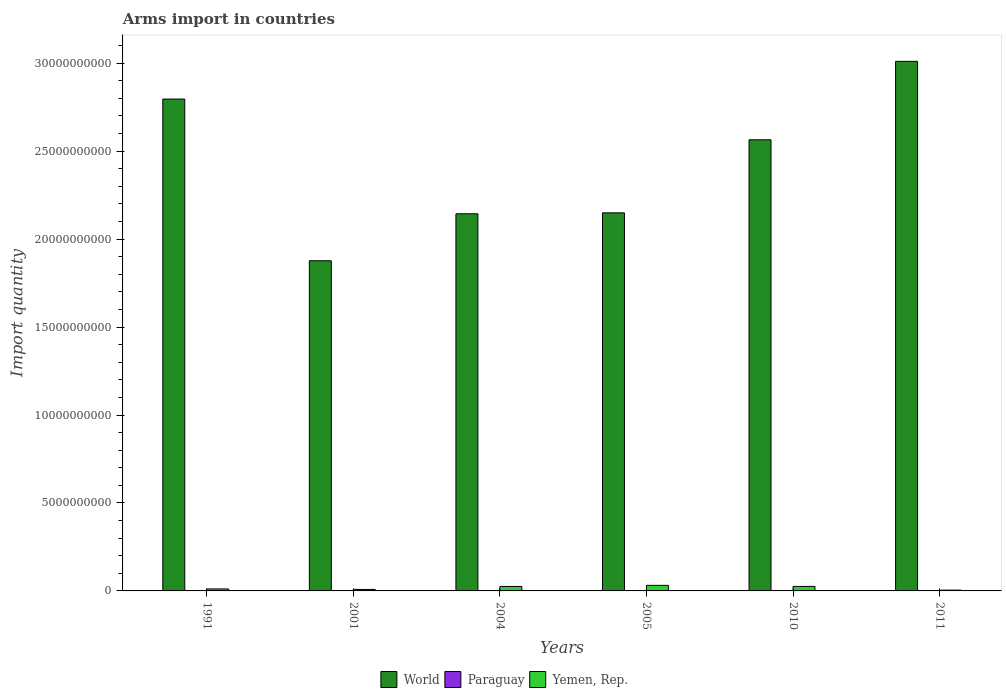How many different coloured bars are there?
Offer a terse response. 3. Are the number of bars per tick equal to the number of legend labels?
Your response must be concise. Yes. How many bars are there on the 4th tick from the left?
Your answer should be compact. 3. What is the label of the 4th group of bars from the left?
Offer a very short reply. 2005. In how many cases, is the number of bars for a given year not equal to the number of legend labels?
Offer a very short reply. 0. Across all years, what is the minimum total arms import in Yemen, Rep.?
Your answer should be compact. 4.50e+07. In which year was the total arms import in Yemen, Rep. maximum?
Ensure brevity in your answer.  2005. What is the total total arms import in World in the graph?
Provide a short and direct response. 1.45e+11. What is the difference between the total arms import in World in 2004 and that in 2010?
Provide a short and direct response. -4.21e+09. What is the difference between the total arms import in Paraguay in 2011 and the total arms import in World in 2010?
Keep it short and to the point. -2.56e+1. What is the average total arms import in Yemen, Rep. per year?
Your answer should be very brief. 1.78e+08. In the year 2004, what is the difference between the total arms import in World and total arms import in Paraguay?
Offer a very short reply. 2.14e+1. What is the ratio of the total arms import in World in 2004 to that in 2010?
Provide a short and direct response. 0.84. What is the difference between the highest and the second highest total arms import in Yemen, Rep.?
Your answer should be very brief. 6.10e+07. What is the difference between the highest and the lowest total arms import in World?
Keep it short and to the point. 1.13e+1. Is the sum of the total arms import in Yemen, Rep. in 1991 and 2001 greater than the maximum total arms import in Paraguay across all years?
Offer a terse response. Yes. What does the 1st bar from the left in 2010 represents?
Your response must be concise. World. What does the 1st bar from the right in 2011 represents?
Offer a very short reply. Yemen, Rep. How many years are there in the graph?
Provide a short and direct response. 6. What is the difference between two consecutive major ticks on the Y-axis?
Your response must be concise. 5.00e+09. Are the values on the major ticks of Y-axis written in scientific E-notation?
Make the answer very short. No. Does the graph contain any zero values?
Give a very brief answer. No. Where does the legend appear in the graph?
Your answer should be compact. Bottom center. How many legend labels are there?
Your response must be concise. 3. How are the legend labels stacked?
Offer a very short reply. Horizontal. What is the title of the graph?
Make the answer very short. Arms import in countries. What is the label or title of the Y-axis?
Offer a terse response. Import quantity. What is the Import quantity in World in 1991?
Keep it short and to the point. 2.80e+1. What is the Import quantity in Yemen, Rep. in 1991?
Make the answer very short. 1.13e+08. What is the Import quantity in World in 2001?
Your answer should be compact. 1.88e+1. What is the Import quantity in Yemen, Rep. in 2001?
Offer a terse response. 8.50e+07. What is the Import quantity in World in 2004?
Offer a terse response. 2.14e+1. What is the Import quantity of Paraguay in 2004?
Provide a succinct answer. 4.00e+06. What is the Import quantity in Yemen, Rep. in 2004?
Provide a short and direct response. 2.54e+08. What is the Import quantity of World in 2005?
Your response must be concise. 2.15e+1. What is the Import quantity of Yemen, Rep. in 2005?
Your answer should be very brief. 3.17e+08. What is the Import quantity of World in 2010?
Make the answer very short. 2.56e+1. What is the Import quantity in Yemen, Rep. in 2010?
Provide a succinct answer. 2.56e+08. What is the Import quantity in World in 2011?
Offer a very short reply. 3.01e+1. What is the Import quantity of Paraguay in 2011?
Your response must be concise. 8.00e+06. What is the Import quantity of Yemen, Rep. in 2011?
Offer a very short reply. 4.50e+07. Across all years, what is the maximum Import quantity of World?
Provide a succinct answer. 3.01e+1. Across all years, what is the maximum Import quantity of Paraguay?
Your answer should be compact. 8.00e+06. Across all years, what is the maximum Import quantity in Yemen, Rep.?
Provide a succinct answer. 3.17e+08. Across all years, what is the minimum Import quantity of World?
Your answer should be compact. 1.88e+1. Across all years, what is the minimum Import quantity of Yemen, Rep.?
Provide a succinct answer. 4.50e+07. What is the total Import quantity in World in the graph?
Provide a succinct answer. 1.45e+11. What is the total Import quantity in Paraguay in the graph?
Your response must be concise. 2.50e+07. What is the total Import quantity in Yemen, Rep. in the graph?
Provide a succinct answer. 1.07e+09. What is the difference between the Import quantity in World in 1991 and that in 2001?
Offer a terse response. 9.19e+09. What is the difference between the Import quantity of Paraguay in 1991 and that in 2001?
Your answer should be very brief. -3.00e+06. What is the difference between the Import quantity of Yemen, Rep. in 1991 and that in 2001?
Your response must be concise. 2.80e+07. What is the difference between the Import quantity in World in 1991 and that in 2004?
Make the answer very short. 6.52e+09. What is the difference between the Import quantity of Yemen, Rep. in 1991 and that in 2004?
Give a very brief answer. -1.41e+08. What is the difference between the Import quantity in World in 1991 and that in 2005?
Provide a short and direct response. 6.47e+09. What is the difference between the Import quantity of Yemen, Rep. in 1991 and that in 2005?
Keep it short and to the point. -2.04e+08. What is the difference between the Import quantity of World in 1991 and that in 2010?
Give a very brief answer. 2.32e+09. What is the difference between the Import quantity of Paraguay in 1991 and that in 2010?
Offer a very short reply. 0. What is the difference between the Import quantity of Yemen, Rep. in 1991 and that in 2010?
Your answer should be compact. -1.43e+08. What is the difference between the Import quantity in World in 1991 and that in 2011?
Make the answer very short. -2.14e+09. What is the difference between the Import quantity in Paraguay in 1991 and that in 2011?
Your answer should be very brief. -5.00e+06. What is the difference between the Import quantity in Yemen, Rep. in 1991 and that in 2011?
Your response must be concise. 6.80e+07. What is the difference between the Import quantity of World in 2001 and that in 2004?
Make the answer very short. -2.67e+09. What is the difference between the Import quantity in Paraguay in 2001 and that in 2004?
Your answer should be compact. 2.00e+06. What is the difference between the Import quantity in Yemen, Rep. in 2001 and that in 2004?
Ensure brevity in your answer.  -1.69e+08. What is the difference between the Import quantity of World in 2001 and that in 2005?
Ensure brevity in your answer.  -2.72e+09. What is the difference between the Import quantity of Yemen, Rep. in 2001 and that in 2005?
Make the answer very short. -2.32e+08. What is the difference between the Import quantity of World in 2001 and that in 2010?
Offer a terse response. -6.88e+09. What is the difference between the Import quantity of Yemen, Rep. in 2001 and that in 2010?
Provide a short and direct response. -1.71e+08. What is the difference between the Import quantity in World in 2001 and that in 2011?
Provide a short and direct response. -1.13e+1. What is the difference between the Import quantity of Paraguay in 2001 and that in 2011?
Your answer should be compact. -2.00e+06. What is the difference between the Import quantity in Yemen, Rep. in 2001 and that in 2011?
Your answer should be compact. 4.00e+07. What is the difference between the Import quantity of World in 2004 and that in 2005?
Ensure brevity in your answer.  -5.20e+07. What is the difference between the Import quantity of Yemen, Rep. in 2004 and that in 2005?
Provide a succinct answer. -6.30e+07. What is the difference between the Import quantity of World in 2004 and that in 2010?
Provide a short and direct response. -4.21e+09. What is the difference between the Import quantity in World in 2004 and that in 2011?
Your answer should be compact. -8.66e+09. What is the difference between the Import quantity of Paraguay in 2004 and that in 2011?
Offer a terse response. -4.00e+06. What is the difference between the Import quantity of Yemen, Rep. in 2004 and that in 2011?
Offer a terse response. 2.09e+08. What is the difference between the Import quantity of World in 2005 and that in 2010?
Provide a short and direct response. -4.15e+09. What is the difference between the Import quantity of Yemen, Rep. in 2005 and that in 2010?
Provide a succinct answer. 6.10e+07. What is the difference between the Import quantity of World in 2005 and that in 2011?
Ensure brevity in your answer.  -8.61e+09. What is the difference between the Import quantity of Paraguay in 2005 and that in 2011?
Make the answer very short. -7.00e+06. What is the difference between the Import quantity of Yemen, Rep. in 2005 and that in 2011?
Make the answer very short. 2.72e+08. What is the difference between the Import quantity in World in 2010 and that in 2011?
Offer a terse response. -4.46e+09. What is the difference between the Import quantity in Paraguay in 2010 and that in 2011?
Offer a very short reply. -5.00e+06. What is the difference between the Import quantity in Yemen, Rep. in 2010 and that in 2011?
Your response must be concise. 2.11e+08. What is the difference between the Import quantity of World in 1991 and the Import quantity of Paraguay in 2001?
Give a very brief answer. 2.80e+1. What is the difference between the Import quantity in World in 1991 and the Import quantity in Yemen, Rep. in 2001?
Offer a very short reply. 2.79e+1. What is the difference between the Import quantity of Paraguay in 1991 and the Import quantity of Yemen, Rep. in 2001?
Your answer should be very brief. -8.20e+07. What is the difference between the Import quantity of World in 1991 and the Import quantity of Paraguay in 2004?
Your answer should be compact. 2.80e+1. What is the difference between the Import quantity of World in 1991 and the Import quantity of Yemen, Rep. in 2004?
Offer a very short reply. 2.77e+1. What is the difference between the Import quantity in Paraguay in 1991 and the Import quantity in Yemen, Rep. in 2004?
Your response must be concise. -2.51e+08. What is the difference between the Import quantity of World in 1991 and the Import quantity of Paraguay in 2005?
Give a very brief answer. 2.80e+1. What is the difference between the Import quantity of World in 1991 and the Import quantity of Yemen, Rep. in 2005?
Make the answer very short. 2.76e+1. What is the difference between the Import quantity in Paraguay in 1991 and the Import quantity in Yemen, Rep. in 2005?
Offer a very short reply. -3.14e+08. What is the difference between the Import quantity in World in 1991 and the Import quantity in Paraguay in 2010?
Your answer should be compact. 2.80e+1. What is the difference between the Import quantity in World in 1991 and the Import quantity in Yemen, Rep. in 2010?
Make the answer very short. 2.77e+1. What is the difference between the Import quantity of Paraguay in 1991 and the Import quantity of Yemen, Rep. in 2010?
Give a very brief answer. -2.53e+08. What is the difference between the Import quantity of World in 1991 and the Import quantity of Paraguay in 2011?
Offer a terse response. 2.80e+1. What is the difference between the Import quantity in World in 1991 and the Import quantity in Yemen, Rep. in 2011?
Offer a very short reply. 2.79e+1. What is the difference between the Import quantity in Paraguay in 1991 and the Import quantity in Yemen, Rep. in 2011?
Provide a succinct answer. -4.20e+07. What is the difference between the Import quantity in World in 2001 and the Import quantity in Paraguay in 2004?
Your response must be concise. 1.88e+1. What is the difference between the Import quantity of World in 2001 and the Import quantity of Yemen, Rep. in 2004?
Ensure brevity in your answer.  1.85e+1. What is the difference between the Import quantity of Paraguay in 2001 and the Import quantity of Yemen, Rep. in 2004?
Provide a short and direct response. -2.48e+08. What is the difference between the Import quantity of World in 2001 and the Import quantity of Paraguay in 2005?
Your response must be concise. 1.88e+1. What is the difference between the Import quantity of World in 2001 and the Import quantity of Yemen, Rep. in 2005?
Provide a short and direct response. 1.85e+1. What is the difference between the Import quantity of Paraguay in 2001 and the Import quantity of Yemen, Rep. in 2005?
Provide a short and direct response. -3.11e+08. What is the difference between the Import quantity of World in 2001 and the Import quantity of Paraguay in 2010?
Make the answer very short. 1.88e+1. What is the difference between the Import quantity of World in 2001 and the Import quantity of Yemen, Rep. in 2010?
Keep it short and to the point. 1.85e+1. What is the difference between the Import quantity of Paraguay in 2001 and the Import quantity of Yemen, Rep. in 2010?
Ensure brevity in your answer.  -2.50e+08. What is the difference between the Import quantity of World in 2001 and the Import quantity of Paraguay in 2011?
Ensure brevity in your answer.  1.88e+1. What is the difference between the Import quantity in World in 2001 and the Import quantity in Yemen, Rep. in 2011?
Provide a short and direct response. 1.87e+1. What is the difference between the Import quantity of Paraguay in 2001 and the Import quantity of Yemen, Rep. in 2011?
Provide a succinct answer. -3.90e+07. What is the difference between the Import quantity in World in 2004 and the Import quantity in Paraguay in 2005?
Your answer should be very brief. 2.14e+1. What is the difference between the Import quantity of World in 2004 and the Import quantity of Yemen, Rep. in 2005?
Keep it short and to the point. 2.11e+1. What is the difference between the Import quantity in Paraguay in 2004 and the Import quantity in Yemen, Rep. in 2005?
Offer a very short reply. -3.13e+08. What is the difference between the Import quantity in World in 2004 and the Import quantity in Paraguay in 2010?
Provide a succinct answer. 2.14e+1. What is the difference between the Import quantity of World in 2004 and the Import quantity of Yemen, Rep. in 2010?
Keep it short and to the point. 2.12e+1. What is the difference between the Import quantity in Paraguay in 2004 and the Import quantity in Yemen, Rep. in 2010?
Offer a terse response. -2.52e+08. What is the difference between the Import quantity of World in 2004 and the Import quantity of Paraguay in 2011?
Your response must be concise. 2.14e+1. What is the difference between the Import quantity in World in 2004 and the Import quantity in Yemen, Rep. in 2011?
Make the answer very short. 2.14e+1. What is the difference between the Import quantity in Paraguay in 2004 and the Import quantity in Yemen, Rep. in 2011?
Offer a terse response. -4.10e+07. What is the difference between the Import quantity of World in 2005 and the Import quantity of Paraguay in 2010?
Keep it short and to the point. 2.15e+1. What is the difference between the Import quantity of World in 2005 and the Import quantity of Yemen, Rep. in 2010?
Offer a very short reply. 2.12e+1. What is the difference between the Import quantity of Paraguay in 2005 and the Import quantity of Yemen, Rep. in 2010?
Give a very brief answer. -2.55e+08. What is the difference between the Import quantity in World in 2005 and the Import quantity in Paraguay in 2011?
Provide a succinct answer. 2.15e+1. What is the difference between the Import quantity in World in 2005 and the Import quantity in Yemen, Rep. in 2011?
Provide a succinct answer. 2.14e+1. What is the difference between the Import quantity in Paraguay in 2005 and the Import quantity in Yemen, Rep. in 2011?
Provide a short and direct response. -4.40e+07. What is the difference between the Import quantity of World in 2010 and the Import quantity of Paraguay in 2011?
Offer a very short reply. 2.56e+1. What is the difference between the Import quantity in World in 2010 and the Import quantity in Yemen, Rep. in 2011?
Keep it short and to the point. 2.56e+1. What is the difference between the Import quantity of Paraguay in 2010 and the Import quantity of Yemen, Rep. in 2011?
Provide a succinct answer. -4.20e+07. What is the average Import quantity of World per year?
Keep it short and to the point. 2.42e+1. What is the average Import quantity in Paraguay per year?
Your answer should be compact. 4.17e+06. What is the average Import quantity of Yemen, Rep. per year?
Give a very brief answer. 1.78e+08. In the year 1991, what is the difference between the Import quantity in World and Import quantity in Paraguay?
Ensure brevity in your answer.  2.80e+1. In the year 1991, what is the difference between the Import quantity in World and Import quantity in Yemen, Rep.?
Provide a succinct answer. 2.78e+1. In the year 1991, what is the difference between the Import quantity of Paraguay and Import quantity of Yemen, Rep.?
Ensure brevity in your answer.  -1.10e+08. In the year 2001, what is the difference between the Import quantity of World and Import quantity of Paraguay?
Provide a succinct answer. 1.88e+1. In the year 2001, what is the difference between the Import quantity in World and Import quantity in Yemen, Rep.?
Provide a succinct answer. 1.87e+1. In the year 2001, what is the difference between the Import quantity of Paraguay and Import quantity of Yemen, Rep.?
Offer a terse response. -7.90e+07. In the year 2004, what is the difference between the Import quantity of World and Import quantity of Paraguay?
Offer a very short reply. 2.14e+1. In the year 2004, what is the difference between the Import quantity of World and Import quantity of Yemen, Rep.?
Offer a very short reply. 2.12e+1. In the year 2004, what is the difference between the Import quantity of Paraguay and Import quantity of Yemen, Rep.?
Offer a terse response. -2.50e+08. In the year 2005, what is the difference between the Import quantity in World and Import quantity in Paraguay?
Provide a succinct answer. 2.15e+1. In the year 2005, what is the difference between the Import quantity of World and Import quantity of Yemen, Rep.?
Make the answer very short. 2.12e+1. In the year 2005, what is the difference between the Import quantity in Paraguay and Import quantity in Yemen, Rep.?
Provide a succinct answer. -3.16e+08. In the year 2010, what is the difference between the Import quantity in World and Import quantity in Paraguay?
Your answer should be very brief. 2.56e+1. In the year 2010, what is the difference between the Import quantity of World and Import quantity of Yemen, Rep.?
Make the answer very short. 2.54e+1. In the year 2010, what is the difference between the Import quantity in Paraguay and Import quantity in Yemen, Rep.?
Provide a short and direct response. -2.53e+08. In the year 2011, what is the difference between the Import quantity of World and Import quantity of Paraguay?
Your answer should be very brief. 3.01e+1. In the year 2011, what is the difference between the Import quantity of World and Import quantity of Yemen, Rep.?
Give a very brief answer. 3.01e+1. In the year 2011, what is the difference between the Import quantity in Paraguay and Import quantity in Yemen, Rep.?
Your answer should be compact. -3.70e+07. What is the ratio of the Import quantity of World in 1991 to that in 2001?
Provide a short and direct response. 1.49. What is the ratio of the Import quantity of Yemen, Rep. in 1991 to that in 2001?
Provide a succinct answer. 1.33. What is the ratio of the Import quantity of World in 1991 to that in 2004?
Your answer should be very brief. 1.3. What is the ratio of the Import quantity in Paraguay in 1991 to that in 2004?
Provide a short and direct response. 0.75. What is the ratio of the Import quantity in Yemen, Rep. in 1991 to that in 2004?
Offer a terse response. 0.44. What is the ratio of the Import quantity in World in 1991 to that in 2005?
Provide a succinct answer. 1.3. What is the ratio of the Import quantity of Yemen, Rep. in 1991 to that in 2005?
Your response must be concise. 0.36. What is the ratio of the Import quantity of World in 1991 to that in 2010?
Your response must be concise. 1.09. What is the ratio of the Import quantity of Yemen, Rep. in 1991 to that in 2010?
Ensure brevity in your answer.  0.44. What is the ratio of the Import quantity of World in 1991 to that in 2011?
Your answer should be compact. 0.93. What is the ratio of the Import quantity of Yemen, Rep. in 1991 to that in 2011?
Give a very brief answer. 2.51. What is the ratio of the Import quantity in World in 2001 to that in 2004?
Give a very brief answer. 0.88. What is the ratio of the Import quantity in Paraguay in 2001 to that in 2004?
Your answer should be very brief. 1.5. What is the ratio of the Import quantity of Yemen, Rep. in 2001 to that in 2004?
Provide a short and direct response. 0.33. What is the ratio of the Import quantity in World in 2001 to that in 2005?
Your answer should be very brief. 0.87. What is the ratio of the Import quantity in Paraguay in 2001 to that in 2005?
Provide a succinct answer. 6. What is the ratio of the Import quantity in Yemen, Rep. in 2001 to that in 2005?
Provide a succinct answer. 0.27. What is the ratio of the Import quantity of World in 2001 to that in 2010?
Offer a very short reply. 0.73. What is the ratio of the Import quantity of Paraguay in 2001 to that in 2010?
Your answer should be compact. 2. What is the ratio of the Import quantity in Yemen, Rep. in 2001 to that in 2010?
Your answer should be very brief. 0.33. What is the ratio of the Import quantity of World in 2001 to that in 2011?
Offer a terse response. 0.62. What is the ratio of the Import quantity in Paraguay in 2001 to that in 2011?
Provide a short and direct response. 0.75. What is the ratio of the Import quantity in Yemen, Rep. in 2001 to that in 2011?
Keep it short and to the point. 1.89. What is the ratio of the Import quantity of World in 2004 to that in 2005?
Your answer should be compact. 1. What is the ratio of the Import quantity in Paraguay in 2004 to that in 2005?
Your answer should be compact. 4. What is the ratio of the Import quantity of Yemen, Rep. in 2004 to that in 2005?
Offer a terse response. 0.8. What is the ratio of the Import quantity of World in 2004 to that in 2010?
Your answer should be compact. 0.84. What is the ratio of the Import quantity in Paraguay in 2004 to that in 2010?
Keep it short and to the point. 1.33. What is the ratio of the Import quantity in Yemen, Rep. in 2004 to that in 2010?
Provide a succinct answer. 0.99. What is the ratio of the Import quantity in World in 2004 to that in 2011?
Make the answer very short. 0.71. What is the ratio of the Import quantity of Paraguay in 2004 to that in 2011?
Offer a terse response. 0.5. What is the ratio of the Import quantity in Yemen, Rep. in 2004 to that in 2011?
Offer a terse response. 5.64. What is the ratio of the Import quantity of World in 2005 to that in 2010?
Keep it short and to the point. 0.84. What is the ratio of the Import quantity of Yemen, Rep. in 2005 to that in 2010?
Provide a short and direct response. 1.24. What is the ratio of the Import quantity of World in 2005 to that in 2011?
Offer a terse response. 0.71. What is the ratio of the Import quantity of Paraguay in 2005 to that in 2011?
Offer a very short reply. 0.12. What is the ratio of the Import quantity in Yemen, Rep. in 2005 to that in 2011?
Provide a short and direct response. 7.04. What is the ratio of the Import quantity of World in 2010 to that in 2011?
Give a very brief answer. 0.85. What is the ratio of the Import quantity of Paraguay in 2010 to that in 2011?
Provide a short and direct response. 0.38. What is the ratio of the Import quantity in Yemen, Rep. in 2010 to that in 2011?
Offer a terse response. 5.69. What is the difference between the highest and the second highest Import quantity of World?
Your response must be concise. 2.14e+09. What is the difference between the highest and the second highest Import quantity of Yemen, Rep.?
Your answer should be compact. 6.10e+07. What is the difference between the highest and the lowest Import quantity in World?
Give a very brief answer. 1.13e+1. What is the difference between the highest and the lowest Import quantity in Yemen, Rep.?
Offer a terse response. 2.72e+08. 